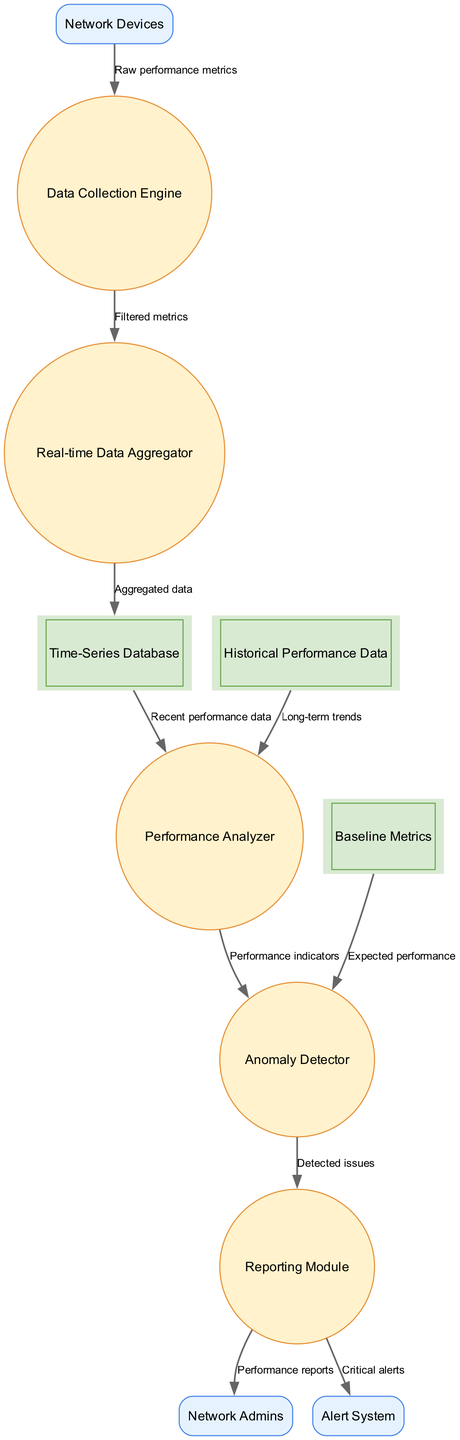What are the external entities in the diagram? The external entities listed include Network Devices, Network Admins, and Alert System.
Answer: Network Devices, Network Admins, Alert System How many processes are present in the diagram? The diagram lists five processes: Data Collection Engine, Real-time Data Aggregator, Performance Analyzer, Anomaly Detector, and Reporting Module. Counting these gives us a total of five processes.
Answer: Five What type of data is sent from the Network Devices to the Data Collection Engine? The data flow label between these two nodes indicates that the type of data sent is "Raw performance metrics." This represents the initial data received from the network devices.
Answer: Raw performance metrics Which process receives data from both the Time-Series Database and Historical Performance Data? The Performance Analyzer node receives data from two sources: Time-Series Database (for recent performance data) and Historical Performance Data (for long-term trends), demonstrating its role in analyzing performance.
Answer: Performance Analyzer What is the final destination of the 'Detected issues' data flow? The 'Detected issues' flow originates from the Anomaly Detector and is directed to the Reporting Module, indicating that the module is responsible for handling reports of any detected issues in network performance.
Answer: Reporting Module Which data store provides expected performance data to the Anomaly Detector? The Baseline Metrics data store provides the expected performance data to the Anomaly Detector, allowing it to compare real-time metrics against established baseline standards.
Answer: Baseline Metrics How many data stores are shown in the diagram? The diagram includes three data stores: Time-Series Database, Historical Performance Data, and Baseline Metrics. This gives a total of three data stores being utilized in the system.
Answer: Three What is the label for the data flow between the Real-time Data Aggregator and the Time-Series Database? The label of the data flow connecting these nodes indicates that the type of data being transferred is "Aggregated data." This signifies that the aggregating process consolidates the data before storage.
Answer: Aggregated data Which external entity receives performance reports from the Reporting Module? The Reporting Module sends performance reports directly to the Network Admins, indicating that they are the recipients of the final reporting output from the monitoring system.
Answer: Network Admins 